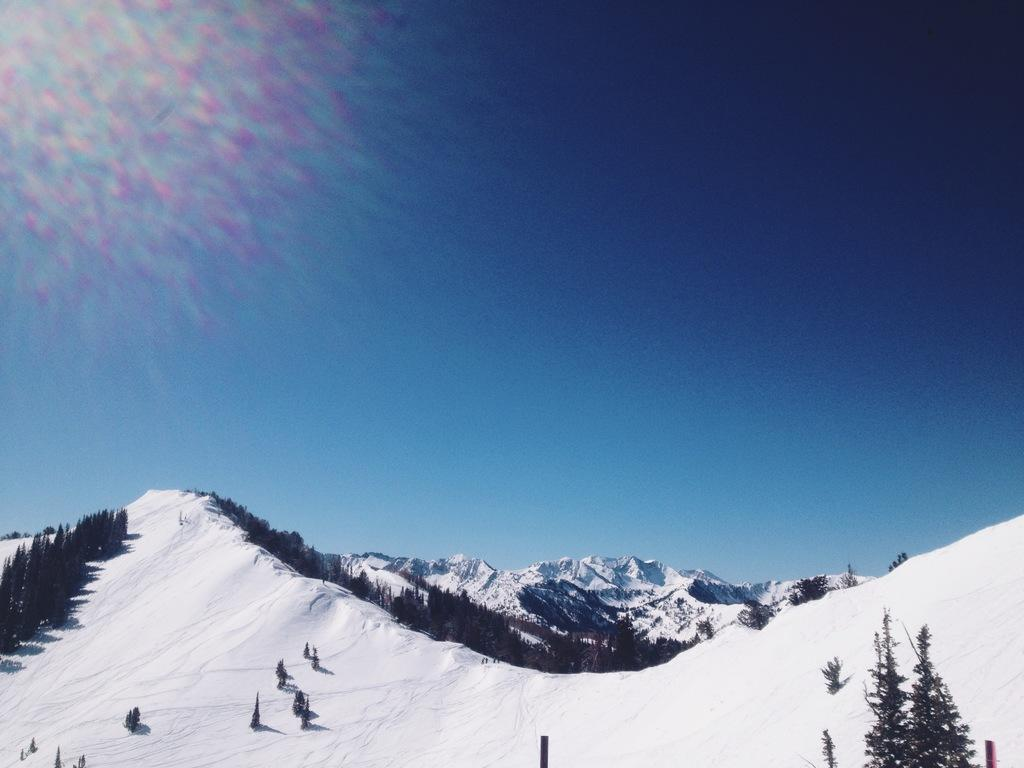What type of vegetation can be seen in the image? There are trees in the image. What type of geographical feature is visible in the image? There are snowy mountains in the image. What part of the natural environment is visible in the image? The sky is visible in the image. What is the price of the quill in the image? There is no quill present in the image, so it is not possible to determine its price. 